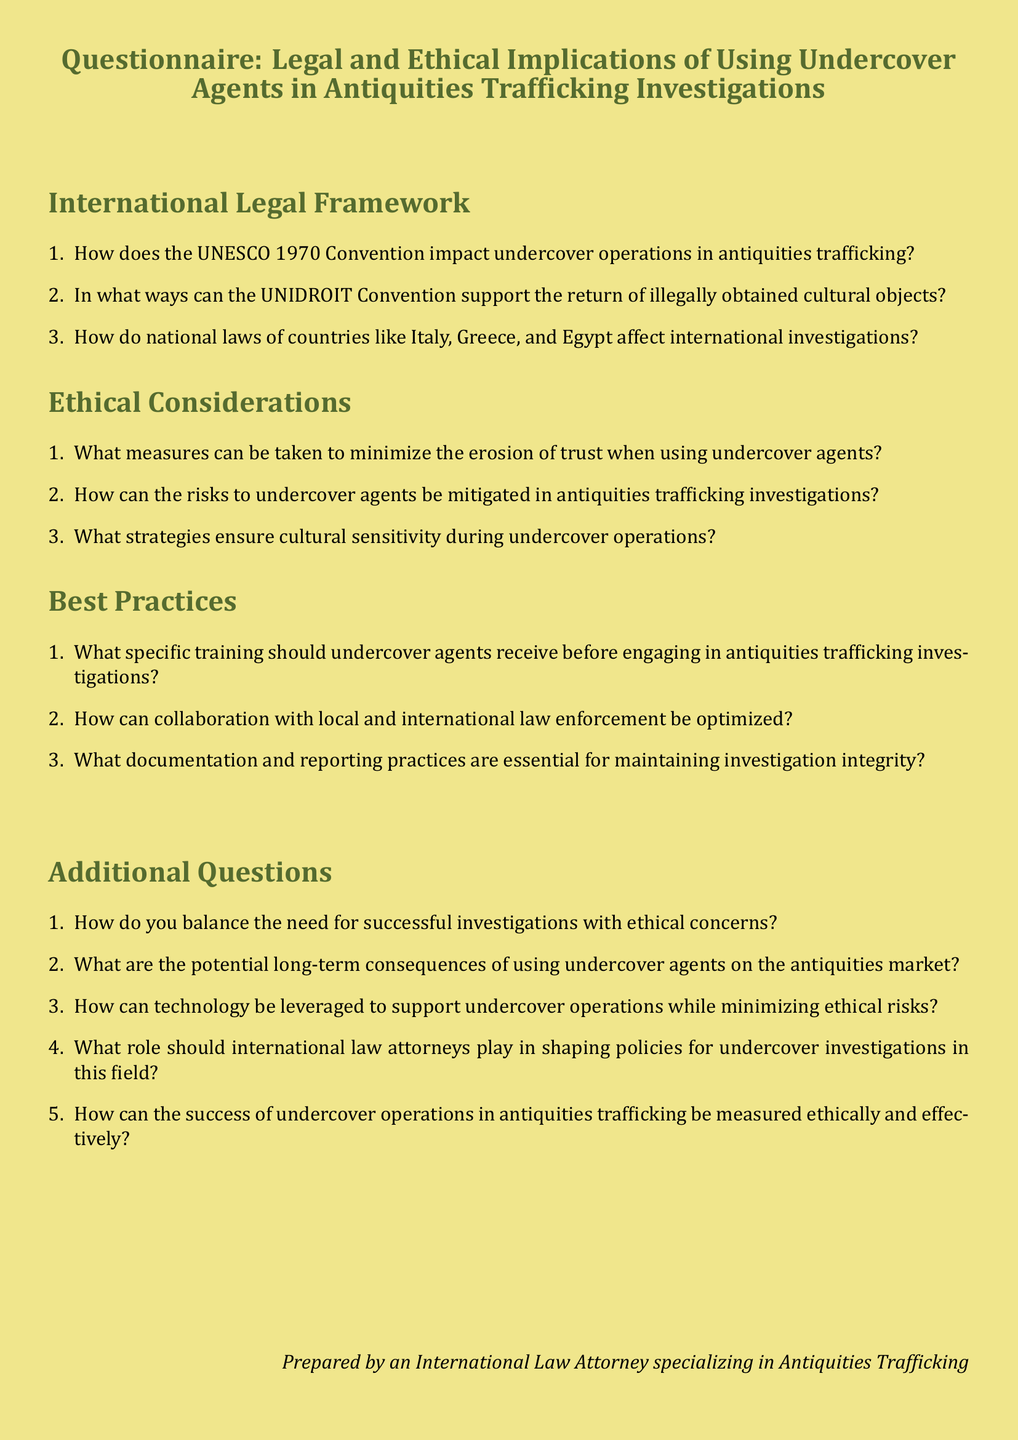What is the title of the document? The title is the central heading that introduces the document content, specifically referring to the questionnaire presented.
Answer: Questionnaire: Legal and Ethical Implications of Using Undercover Agents in Antiquities Trafficking Investigations How many sections are in the questionnaire? The document includes three main sections plus additional questions, thus a total of four sections can be counted.
Answer: Four What is one international legal framework mentioned? The document specifies a convention related to international legal frameworks regarding cultural heritage protection, which directly impacts undercover operations.
Answer: UNESCO 1970 Convention What type of measures can be taken to maintain trust? The questionnaire offers an ethical consideration that prompts reflection on measures taken in the context of investigative operations and agent deployment.
Answer: Minimize erosion of trust How many questions are listed under Ethical Considerations? This counts the questions specifically outlined in the Ethical Considerations section of the document, showing the focus on these ethical aspects.
Answer: Three What strategies are emphasized for cultural sensitivity? The document lists ethical considerations that relate to undercover strategies, highlighting the importance of understanding cultural contexts.
Answer: Ensure cultural sensitivity What role should international law attorneys play? This is a specific inquiry raised within the additional questions directed towards the contributions of legal professionals in shaping investigation policies.
Answer: Shaping policies How can the success of operations be measured? The document poses a reflective additional question aimed at determining the evaluation metrics employed in assessing the effectiveness of undercover engagements.
Answer: Ethically and effectively What training should undercover agents receive? The questionnaire details the necessary preparations required for agents prior to engaging in specific investigative activities.
Answer: Specific training 